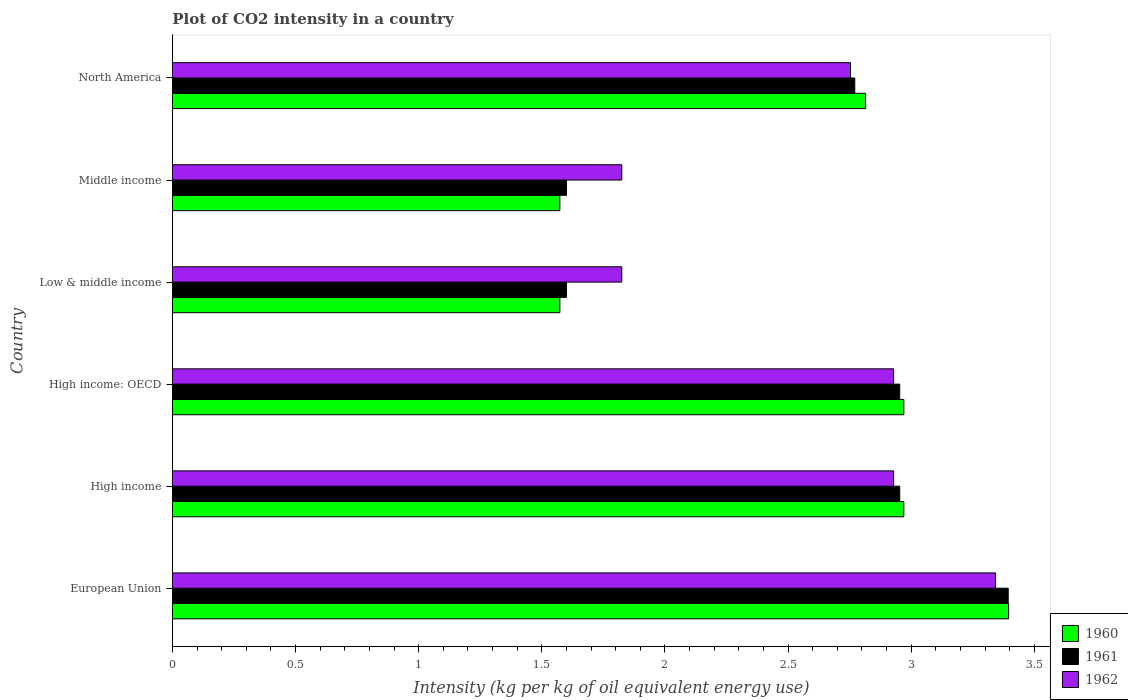How many bars are there on the 3rd tick from the top?
Offer a terse response. 3. What is the CO2 intensity in in 1962 in Low & middle income?
Give a very brief answer. 1.82. Across all countries, what is the maximum CO2 intensity in in 1962?
Offer a terse response. 3.34. Across all countries, what is the minimum CO2 intensity in in 1962?
Keep it short and to the point. 1.82. In which country was the CO2 intensity in in 1961 maximum?
Offer a very short reply. European Union. In which country was the CO2 intensity in in 1961 minimum?
Make the answer very short. Low & middle income. What is the total CO2 intensity in in 1960 in the graph?
Provide a short and direct response. 15.3. What is the difference between the CO2 intensity in in 1960 in High income: OECD and that in Middle income?
Your answer should be compact. 1.4. What is the difference between the CO2 intensity in in 1961 in North America and the CO2 intensity in in 1962 in High income?
Offer a very short reply. -0.16. What is the average CO2 intensity in in 1962 per country?
Keep it short and to the point. 2.6. What is the difference between the CO2 intensity in in 1962 and CO2 intensity in in 1960 in Middle income?
Offer a very short reply. 0.25. What is the ratio of the CO2 intensity in in 1961 in Low & middle income to that in North America?
Offer a very short reply. 0.58. Is the CO2 intensity in in 1962 in High income less than that in Middle income?
Provide a short and direct response. No. Is the difference between the CO2 intensity in in 1962 in High income and Middle income greater than the difference between the CO2 intensity in in 1960 in High income and Middle income?
Your response must be concise. No. What is the difference between the highest and the second highest CO2 intensity in in 1961?
Provide a succinct answer. 0.44. What is the difference between the highest and the lowest CO2 intensity in in 1960?
Give a very brief answer. 1.82. What does the 3rd bar from the top in Middle income represents?
Make the answer very short. 1960. What does the 1st bar from the bottom in North America represents?
Your answer should be compact. 1960. What is the difference between two consecutive major ticks on the X-axis?
Your response must be concise. 0.5. How many legend labels are there?
Make the answer very short. 3. How are the legend labels stacked?
Your answer should be compact. Vertical. What is the title of the graph?
Make the answer very short. Plot of CO2 intensity in a country. Does "1978" appear as one of the legend labels in the graph?
Offer a terse response. No. What is the label or title of the X-axis?
Make the answer very short. Intensity (kg per kg of oil equivalent energy use). What is the Intensity (kg per kg of oil equivalent energy use) in 1960 in European Union?
Your response must be concise. 3.4. What is the Intensity (kg per kg of oil equivalent energy use) in 1961 in European Union?
Keep it short and to the point. 3.39. What is the Intensity (kg per kg of oil equivalent energy use) in 1962 in European Union?
Give a very brief answer. 3.34. What is the Intensity (kg per kg of oil equivalent energy use) of 1960 in High income?
Make the answer very short. 2.97. What is the Intensity (kg per kg of oil equivalent energy use) of 1961 in High income?
Give a very brief answer. 2.95. What is the Intensity (kg per kg of oil equivalent energy use) of 1962 in High income?
Offer a terse response. 2.93. What is the Intensity (kg per kg of oil equivalent energy use) of 1960 in High income: OECD?
Offer a very short reply. 2.97. What is the Intensity (kg per kg of oil equivalent energy use) in 1961 in High income: OECD?
Keep it short and to the point. 2.95. What is the Intensity (kg per kg of oil equivalent energy use) of 1962 in High income: OECD?
Your answer should be very brief. 2.93. What is the Intensity (kg per kg of oil equivalent energy use) of 1960 in Low & middle income?
Offer a very short reply. 1.57. What is the Intensity (kg per kg of oil equivalent energy use) of 1961 in Low & middle income?
Make the answer very short. 1.6. What is the Intensity (kg per kg of oil equivalent energy use) of 1962 in Low & middle income?
Give a very brief answer. 1.82. What is the Intensity (kg per kg of oil equivalent energy use) of 1960 in Middle income?
Your answer should be very brief. 1.57. What is the Intensity (kg per kg of oil equivalent energy use) of 1961 in Middle income?
Keep it short and to the point. 1.6. What is the Intensity (kg per kg of oil equivalent energy use) of 1962 in Middle income?
Offer a terse response. 1.82. What is the Intensity (kg per kg of oil equivalent energy use) of 1960 in North America?
Provide a short and direct response. 2.81. What is the Intensity (kg per kg of oil equivalent energy use) of 1961 in North America?
Offer a very short reply. 2.77. What is the Intensity (kg per kg of oil equivalent energy use) of 1962 in North America?
Ensure brevity in your answer.  2.75. Across all countries, what is the maximum Intensity (kg per kg of oil equivalent energy use) of 1960?
Make the answer very short. 3.4. Across all countries, what is the maximum Intensity (kg per kg of oil equivalent energy use) in 1961?
Make the answer very short. 3.39. Across all countries, what is the maximum Intensity (kg per kg of oil equivalent energy use) of 1962?
Offer a very short reply. 3.34. Across all countries, what is the minimum Intensity (kg per kg of oil equivalent energy use) of 1960?
Make the answer very short. 1.57. Across all countries, what is the minimum Intensity (kg per kg of oil equivalent energy use) of 1961?
Your answer should be compact. 1.6. Across all countries, what is the minimum Intensity (kg per kg of oil equivalent energy use) in 1962?
Provide a short and direct response. 1.82. What is the total Intensity (kg per kg of oil equivalent energy use) in 1960 in the graph?
Provide a short and direct response. 15.3. What is the total Intensity (kg per kg of oil equivalent energy use) of 1961 in the graph?
Offer a terse response. 15.27. What is the total Intensity (kg per kg of oil equivalent energy use) in 1962 in the graph?
Ensure brevity in your answer.  15.6. What is the difference between the Intensity (kg per kg of oil equivalent energy use) in 1960 in European Union and that in High income?
Your answer should be compact. 0.43. What is the difference between the Intensity (kg per kg of oil equivalent energy use) in 1961 in European Union and that in High income?
Give a very brief answer. 0.44. What is the difference between the Intensity (kg per kg of oil equivalent energy use) of 1962 in European Union and that in High income?
Offer a terse response. 0.41. What is the difference between the Intensity (kg per kg of oil equivalent energy use) of 1960 in European Union and that in High income: OECD?
Give a very brief answer. 0.43. What is the difference between the Intensity (kg per kg of oil equivalent energy use) in 1961 in European Union and that in High income: OECD?
Provide a short and direct response. 0.44. What is the difference between the Intensity (kg per kg of oil equivalent energy use) in 1962 in European Union and that in High income: OECD?
Offer a very short reply. 0.41. What is the difference between the Intensity (kg per kg of oil equivalent energy use) of 1960 in European Union and that in Low & middle income?
Provide a short and direct response. 1.82. What is the difference between the Intensity (kg per kg of oil equivalent energy use) in 1961 in European Union and that in Low & middle income?
Make the answer very short. 1.79. What is the difference between the Intensity (kg per kg of oil equivalent energy use) of 1962 in European Union and that in Low & middle income?
Give a very brief answer. 1.52. What is the difference between the Intensity (kg per kg of oil equivalent energy use) of 1960 in European Union and that in Middle income?
Provide a succinct answer. 1.82. What is the difference between the Intensity (kg per kg of oil equivalent energy use) of 1961 in European Union and that in Middle income?
Provide a short and direct response. 1.79. What is the difference between the Intensity (kg per kg of oil equivalent energy use) of 1962 in European Union and that in Middle income?
Your response must be concise. 1.52. What is the difference between the Intensity (kg per kg of oil equivalent energy use) in 1960 in European Union and that in North America?
Keep it short and to the point. 0.58. What is the difference between the Intensity (kg per kg of oil equivalent energy use) of 1961 in European Union and that in North America?
Offer a terse response. 0.62. What is the difference between the Intensity (kg per kg of oil equivalent energy use) in 1962 in European Union and that in North America?
Ensure brevity in your answer.  0.59. What is the difference between the Intensity (kg per kg of oil equivalent energy use) in 1960 in High income and that in High income: OECD?
Offer a terse response. 0. What is the difference between the Intensity (kg per kg of oil equivalent energy use) in 1961 in High income and that in High income: OECD?
Provide a succinct answer. 0. What is the difference between the Intensity (kg per kg of oil equivalent energy use) in 1962 in High income and that in High income: OECD?
Your answer should be very brief. 0. What is the difference between the Intensity (kg per kg of oil equivalent energy use) in 1960 in High income and that in Low & middle income?
Your answer should be compact. 1.4. What is the difference between the Intensity (kg per kg of oil equivalent energy use) of 1961 in High income and that in Low & middle income?
Make the answer very short. 1.35. What is the difference between the Intensity (kg per kg of oil equivalent energy use) of 1962 in High income and that in Low & middle income?
Provide a short and direct response. 1.1. What is the difference between the Intensity (kg per kg of oil equivalent energy use) of 1960 in High income and that in Middle income?
Your response must be concise. 1.4. What is the difference between the Intensity (kg per kg of oil equivalent energy use) in 1961 in High income and that in Middle income?
Offer a very short reply. 1.35. What is the difference between the Intensity (kg per kg of oil equivalent energy use) of 1962 in High income and that in Middle income?
Your answer should be very brief. 1.1. What is the difference between the Intensity (kg per kg of oil equivalent energy use) of 1960 in High income and that in North America?
Provide a succinct answer. 0.16. What is the difference between the Intensity (kg per kg of oil equivalent energy use) in 1961 in High income and that in North America?
Your answer should be very brief. 0.18. What is the difference between the Intensity (kg per kg of oil equivalent energy use) of 1962 in High income and that in North America?
Provide a short and direct response. 0.18. What is the difference between the Intensity (kg per kg of oil equivalent energy use) in 1960 in High income: OECD and that in Low & middle income?
Your response must be concise. 1.4. What is the difference between the Intensity (kg per kg of oil equivalent energy use) of 1961 in High income: OECD and that in Low & middle income?
Make the answer very short. 1.35. What is the difference between the Intensity (kg per kg of oil equivalent energy use) in 1962 in High income: OECD and that in Low & middle income?
Your response must be concise. 1.1. What is the difference between the Intensity (kg per kg of oil equivalent energy use) of 1960 in High income: OECD and that in Middle income?
Your response must be concise. 1.4. What is the difference between the Intensity (kg per kg of oil equivalent energy use) of 1961 in High income: OECD and that in Middle income?
Provide a succinct answer. 1.35. What is the difference between the Intensity (kg per kg of oil equivalent energy use) of 1962 in High income: OECD and that in Middle income?
Provide a short and direct response. 1.1. What is the difference between the Intensity (kg per kg of oil equivalent energy use) of 1960 in High income: OECD and that in North America?
Provide a succinct answer. 0.16. What is the difference between the Intensity (kg per kg of oil equivalent energy use) in 1961 in High income: OECD and that in North America?
Your answer should be compact. 0.18. What is the difference between the Intensity (kg per kg of oil equivalent energy use) of 1962 in High income: OECD and that in North America?
Offer a terse response. 0.18. What is the difference between the Intensity (kg per kg of oil equivalent energy use) of 1960 in Low & middle income and that in Middle income?
Your response must be concise. 0. What is the difference between the Intensity (kg per kg of oil equivalent energy use) in 1961 in Low & middle income and that in Middle income?
Provide a short and direct response. 0. What is the difference between the Intensity (kg per kg of oil equivalent energy use) in 1960 in Low & middle income and that in North America?
Your response must be concise. -1.24. What is the difference between the Intensity (kg per kg of oil equivalent energy use) in 1961 in Low & middle income and that in North America?
Make the answer very short. -1.17. What is the difference between the Intensity (kg per kg of oil equivalent energy use) of 1962 in Low & middle income and that in North America?
Offer a terse response. -0.93. What is the difference between the Intensity (kg per kg of oil equivalent energy use) of 1960 in Middle income and that in North America?
Your response must be concise. -1.24. What is the difference between the Intensity (kg per kg of oil equivalent energy use) of 1961 in Middle income and that in North America?
Make the answer very short. -1.17. What is the difference between the Intensity (kg per kg of oil equivalent energy use) in 1962 in Middle income and that in North America?
Make the answer very short. -0.93. What is the difference between the Intensity (kg per kg of oil equivalent energy use) in 1960 in European Union and the Intensity (kg per kg of oil equivalent energy use) in 1961 in High income?
Offer a terse response. 0.44. What is the difference between the Intensity (kg per kg of oil equivalent energy use) of 1960 in European Union and the Intensity (kg per kg of oil equivalent energy use) of 1962 in High income?
Ensure brevity in your answer.  0.47. What is the difference between the Intensity (kg per kg of oil equivalent energy use) in 1961 in European Union and the Intensity (kg per kg of oil equivalent energy use) in 1962 in High income?
Provide a short and direct response. 0.47. What is the difference between the Intensity (kg per kg of oil equivalent energy use) of 1960 in European Union and the Intensity (kg per kg of oil equivalent energy use) of 1961 in High income: OECD?
Your response must be concise. 0.44. What is the difference between the Intensity (kg per kg of oil equivalent energy use) of 1960 in European Union and the Intensity (kg per kg of oil equivalent energy use) of 1962 in High income: OECD?
Provide a short and direct response. 0.47. What is the difference between the Intensity (kg per kg of oil equivalent energy use) in 1961 in European Union and the Intensity (kg per kg of oil equivalent energy use) in 1962 in High income: OECD?
Offer a very short reply. 0.47. What is the difference between the Intensity (kg per kg of oil equivalent energy use) of 1960 in European Union and the Intensity (kg per kg of oil equivalent energy use) of 1961 in Low & middle income?
Offer a very short reply. 1.8. What is the difference between the Intensity (kg per kg of oil equivalent energy use) of 1960 in European Union and the Intensity (kg per kg of oil equivalent energy use) of 1962 in Low & middle income?
Offer a terse response. 1.57. What is the difference between the Intensity (kg per kg of oil equivalent energy use) of 1961 in European Union and the Intensity (kg per kg of oil equivalent energy use) of 1962 in Low & middle income?
Give a very brief answer. 1.57. What is the difference between the Intensity (kg per kg of oil equivalent energy use) in 1960 in European Union and the Intensity (kg per kg of oil equivalent energy use) in 1961 in Middle income?
Provide a short and direct response. 1.8. What is the difference between the Intensity (kg per kg of oil equivalent energy use) of 1960 in European Union and the Intensity (kg per kg of oil equivalent energy use) of 1962 in Middle income?
Provide a succinct answer. 1.57. What is the difference between the Intensity (kg per kg of oil equivalent energy use) of 1961 in European Union and the Intensity (kg per kg of oil equivalent energy use) of 1962 in Middle income?
Offer a very short reply. 1.57. What is the difference between the Intensity (kg per kg of oil equivalent energy use) of 1960 in European Union and the Intensity (kg per kg of oil equivalent energy use) of 1961 in North America?
Provide a short and direct response. 0.62. What is the difference between the Intensity (kg per kg of oil equivalent energy use) in 1960 in European Union and the Intensity (kg per kg of oil equivalent energy use) in 1962 in North America?
Your answer should be very brief. 0.64. What is the difference between the Intensity (kg per kg of oil equivalent energy use) of 1961 in European Union and the Intensity (kg per kg of oil equivalent energy use) of 1962 in North America?
Your answer should be compact. 0.64. What is the difference between the Intensity (kg per kg of oil equivalent energy use) of 1960 in High income and the Intensity (kg per kg of oil equivalent energy use) of 1961 in High income: OECD?
Your response must be concise. 0.02. What is the difference between the Intensity (kg per kg of oil equivalent energy use) of 1960 in High income and the Intensity (kg per kg of oil equivalent energy use) of 1962 in High income: OECD?
Provide a succinct answer. 0.04. What is the difference between the Intensity (kg per kg of oil equivalent energy use) of 1961 in High income and the Intensity (kg per kg of oil equivalent energy use) of 1962 in High income: OECD?
Ensure brevity in your answer.  0.02. What is the difference between the Intensity (kg per kg of oil equivalent energy use) of 1960 in High income and the Intensity (kg per kg of oil equivalent energy use) of 1961 in Low & middle income?
Provide a short and direct response. 1.37. What is the difference between the Intensity (kg per kg of oil equivalent energy use) in 1960 in High income and the Intensity (kg per kg of oil equivalent energy use) in 1962 in Low & middle income?
Offer a terse response. 1.15. What is the difference between the Intensity (kg per kg of oil equivalent energy use) of 1961 in High income and the Intensity (kg per kg of oil equivalent energy use) of 1962 in Low & middle income?
Keep it short and to the point. 1.13. What is the difference between the Intensity (kg per kg of oil equivalent energy use) in 1960 in High income and the Intensity (kg per kg of oil equivalent energy use) in 1961 in Middle income?
Make the answer very short. 1.37. What is the difference between the Intensity (kg per kg of oil equivalent energy use) of 1960 in High income and the Intensity (kg per kg of oil equivalent energy use) of 1962 in Middle income?
Keep it short and to the point. 1.15. What is the difference between the Intensity (kg per kg of oil equivalent energy use) in 1961 in High income and the Intensity (kg per kg of oil equivalent energy use) in 1962 in Middle income?
Offer a very short reply. 1.13. What is the difference between the Intensity (kg per kg of oil equivalent energy use) of 1960 in High income and the Intensity (kg per kg of oil equivalent energy use) of 1961 in North America?
Offer a very short reply. 0.2. What is the difference between the Intensity (kg per kg of oil equivalent energy use) in 1960 in High income and the Intensity (kg per kg of oil equivalent energy use) in 1962 in North America?
Offer a very short reply. 0.22. What is the difference between the Intensity (kg per kg of oil equivalent energy use) of 1961 in High income and the Intensity (kg per kg of oil equivalent energy use) of 1962 in North America?
Ensure brevity in your answer.  0.2. What is the difference between the Intensity (kg per kg of oil equivalent energy use) of 1960 in High income: OECD and the Intensity (kg per kg of oil equivalent energy use) of 1961 in Low & middle income?
Give a very brief answer. 1.37. What is the difference between the Intensity (kg per kg of oil equivalent energy use) in 1960 in High income: OECD and the Intensity (kg per kg of oil equivalent energy use) in 1962 in Low & middle income?
Provide a short and direct response. 1.15. What is the difference between the Intensity (kg per kg of oil equivalent energy use) in 1961 in High income: OECD and the Intensity (kg per kg of oil equivalent energy use) in 1962 in Low & middle income?
Keep it short and to the point. 1.13. What is the difference between the Intensity (kg per kg of oil equivalent energy use) of 1960 in High income: OECD and the Intensity (kg per kg of oil equivalent energy use) of 1961 in Middle income?
Offer a very short reply. 1.37. What is the difference between the Intensity (kg per kg of oil equivalent energy use) in 1960 in High income: OECD and the Intensity (kg per kg of oil equivalent energy use) in 1962 in Middle income?
Provide a short and direct response. 1.15. What is the difference between the Intensity (kg per kg of oil equivalent energy use) in 1961 in High income: OECD and the Intensity (kg per kg of oil equivalent energy use) in 1962 in Middle income?
Offer a very short reply. 1.13. What is the difference between the Intensity (kg per kg of oil equivalent energy use) of 1960 in High income: OECD and the Intensity (kg per kg of oil equivalent energy use) of 1961 in North America?
Make the answer very short. 0.2. What is the difference between the Intensity (kg per kg of oil equivalent energy use) in 1960 in High income: OECD and the Intensity (kg per kg of oil equivalent energy use) in 1962 in North America?
Make the answer very short. 0.22. What is the difference between the Intensity (kg per kg of oil equivalent energy use) of 1961 in High income: OECD and the Intensity (kg per kg of oil equivalent energy use) of 1962 in North America?
Provide a succinct answer. 0.2. What is the difference between the Intensity (kg per kg of oil equivalent energy use) in 1960 in Low & middle income and the Intensity (kg per kg of oil equivalent energy use) in 1961 in Middle income?
Ensure brevity in your answer.  -0.03. What is the difference between the Intensity (kg per kg of oil equivalent energy use) in 1960 in Low & middle income and the Intensity (kg per kg of oil equivalent energy use) in 1962 in Middle income?
Provide a succinct answer. -0.25. What is the difference between the Intensity (kg per kg of oil equivalent energy use) in 1961 in Low & middle income and the Intensity (kg per kg of oil equivalent energy use) in 1962 in Middle income?
Give a very brief answer. -0.22. What is the difference between the Intensity (kg per kg of oil equivalent energy use) in 1960 in Low & middle income and the Intensity (kg per kg of oil equivalent energy use) in 1961 in North America?
Your answer should be compact. -1.2. What is the difference between the Intensity (kg per kg of oil equivalent energy use) of 1960 in Low & middle income and the Intensity (kg per kg of oil equivalent energy use) of 1962 in North America?
Your response must be concise. -1.18. What is the difference between the Intensity (kg per kg of oil equivalent energy use) of 1961 in Low & middle income and the Intensity (kg per kg of oil equivalent energy use) of 1962 in North America?
Offer a terse response. -1.15. What is the difference between the Intensity (kg per kg of oil equivalent energy use) in 1960 in Middle income and the Intensity (kg per kg of oil equivalent energy use) in 1961 in North America?
Ensure brevity in your answer.  -1.2. What is the difference between the Intensity (kg per kg of oil equivalent energy use) in 1960 in Middle income and the Intensity (kg per kg of oil equivalent energy use) in 1962 in North America?
Offer a very short reply. -1.18. What is the difference between the Intensity (kg per kg of oil equivalent energy use) of 1961 in Middle income and the Intensity (kg per kg of oil equivalent energy use) of 1962 in North America?
Your answer should be very brief. -1.15. What is the average Intensity (kg per kg of oil equivalent energy use) of 1960 per country?
Offer a terse response. 2.55. What is the average Intensity (kg per kg of oil equivalent energy use) in 1961 per country?
Offer a very short reply. 2.55. What is the average Intensity (kg per kg of oil equivalent energy use) of 1962 per country?
Ensure brevity in your answer.  2.6. What is the difference between the Intensity (kg per kg of oil equivalent energy use) of 1960 and Intensity (kg per kg of oil equivalent energy use) of 1961 in European Union?
Make the answer very short. 0. What is the difference between the Intensity (kg per kg of oil equivalent energy use) of 1960 and Intensity (kg per kg of oil equivalent energy use) of 1962 in European Union?
Offer a terse response. 0.05. What is the difference between the Intensity (kg per kg of oil equivalent energy use) in 1961 and Intensity (kg per kg of oil equivalent energy use) in 1962 in European Union?
Offer a terse response. 0.05. What is the difference between the Intensity (kg per kg of oil equivalent energy use) in 1960 and Intensity (kg per kg of oil equivalent energy use) in 1961 in High income?
Your answer should be compact. 0.02. What is the difference between the Intensity (kg per kg of oil equivalent energy use) of 1960 and Intensity (kg per kg of oil equivalent energy use) of 1962 in High income?
Your answer should be compact. 0.04. What is the difference between the Intensity (kg per kg of oil equivalent energy use) of 1961 and Intensity (kg per kg of oil equivalent energy use) of 1962 in High income?
Ensure brevity in your answer.  0.02. What is the difference between the Intensity (kg per kg of oil equivalent energy use) of 1960 and Intensity (kg per kg of oil equivalent energy use) of 1961 in High income: OECD?
Give a very brief answer. 0.02. What is the difference between the Intensity (kg per kg of oil equivalent energy use) of 1960 and Intensity (kg per kg of oil equivalent energy use) of 1962 in High income: OECD?
Make the answer very short. 0.04. What is the difference between the Intensity (kg per kg of oil equivalent energy use) in 1961 and Intensity (kg per kg of oil equivalent energy use) in 1962 in High income: OECD?
Offer a very short reply. 0.02. What is the difference between the Intensity (kg per kg of oil equivalent energy use) in 1960 and Intensity (kg per kg of oil equivalent energy use) in 1961 in Low & middle income?
Offer a terse response. -0.03. What is the difference between the Intensity (kg per kg of oil equivalent energy use) of 1960 and Intensity (kg per kg of oil equivalent energy use) of 1962 in Low & middle income?
Your response must be concise. -0.25. What is the difference between the Intensity (kg per kg of oil equivalent energy use) of 1961 and Intensity (kg per kg of oil equivalent energy use) of 1962 in Low & middle income?
Provide a short and direct response. -0.22. What is the difference between the Intensity (kg per kg of oil equivalent energy use) in 1960 and Intensity (kg per kg of oil equivalent energy use) in 1961 in Middle income?
Your response must be concise. -0.03. What is the difference between the Intensity (kg per kg of oil equivalent energy use) in 1960 and Intensity (kg per kg of oil equivalent energy use) in 1962 in Middle income?
Offer a terse response. -0.25. What is the difference between the Intensity (kg per kg of oil equivalent energy use) in 1961 and Intensity (kg per kg of oil equivalent energy use) in 1962 in Middle income?
Offer a terse response. -0.22. What is the difference between the Intensity (kg per kg of oil equivalent energy use) in 1960 and Intensity (kg per kg of oil equivalent energy use) in 1961 in North America?
Your response must be concise. 0.04. What is the difference between the Intensity (kg per kg of oil equivalent energy use) of 1960 and Intensity (kg per kg of oil equivalent energy use) of 1962 in North America?
Provide a succinct answer. 0.06. What is the difference between the Intensity (kg per kg of oil equivalent energy use) of 1961 and Intensity (kg per kg of oil equivalent energy use) of 1962 in North America?
Make the answer very short. 0.02. What is the ratio of the Intensity (kg per kg of oil equivalent energy use) of 1960 in European Union to that in High income?
Provide a short and direct response. 1.14. What is the ratio of the Intensity (kg per kg of oil equivalent energy use) of 1961 in European Union to that in High income?
Provide a succinct answer. 1.15. What is the ratio of the Intensity (kg per kg of oil equivalent energy use) in 1962 in European Union to that in High income?
Keep it short and to the point. 1.14. What is the ratio of the Intensity (kg per kg of oil equivalent energy use) in 1960 in European Union to that in High income: OECD?
Your response must be concise. 1.14. What is the ratio of the Intensity (kg per kg of oil equivalent energy use) of 1961 in European Union to that in High income: OECD?
Your answer should be compact. 1.15. What is the ratio of the Intensity (kg per kg of oil equivalent energy use) in 1962 in European Union to that in High income: OECD?
Give a very brief answer. 1.14. What is the ratio of the Intensity (kg per kg of oil equivalent energy use) in 1960 in European Union to that in Low & middle income?
Give a very brief answer. 2.16. What is the ratio of the Intensity (kg per kg of oil equivalent energy use) in 1961 in European Union to that in Low & middle income?
Your answer should be very brief. 2.12. What is the ratio of the Intensity (kg per kg of oil equivalent energy use) in 1962 in European Union to that in Low & middle income?
Make the answer very short. 1.83. What is the ratio of the Intensity (kg per kg of oil equivalent energy use) of 1960 in European Union to that in Middle income?
Provide a succinct answer. 2.16. What is the ratio of the Intensity (kg per kg of oil equivalent energy use) in 1961 in European Union to that in Middle income?
Your response must be concise. 2.12. What is the ratio of the Intensity (kg per kg of oil equivalent energy use) in 1962 in European Union to that in Middle income?
Your response must be concise. 1.83. What is the ratio of the Intensity (kg per kg of oil equivalent energy use) in 1960 in European Union to that in North America?
Ensure brevity in your answer.  1.21. What is the ratio of the Intensity (kg per kg of oil equivalent energy use) in 1961 in European Union to that in North America?
Your answer should be compact. 1.22. What is the ratio of the Intensity (kg per kg of oil equivalent energy use) in 1962 in European Union to that in North America?
Your response must be concise. 1.21. What is the ratio of the Intensity (kg per kg of oil equivalent energy use) in 1960 in High income to that in High income: OECD?
Provide a short and direct response. 1. What is the ratio of the Intensity (kg per kg of oil equivalent energy use) in 1961 in High income to that in High income: OECD?
Offer a terse response. 1. What is the ratio of the Intensity (kg per kg of oil equivalent energy use) of 1962 in High income to that in High income: OECD?
Give a very brief answer. 1. What is the ratio of the Intensity (kg per kg of oil equivalent energy use) of 1960 in High income to that in Low & middle income?
Your answer should be very brief. 1.89. What is the ratio of the Intensity (kg per kg of oil equivalent energy use) in 1961 in High income to that in Low & middle income?
Provide a short and direct response. 1.85. What is the ratio of the Intensity (kg per kg of oil equivalent energy use) in 1962 in High income to that in Low & middle income?
Your answer should be compact. 1.6. What is the ratio of the Intensity (kg per kg of oil equivalent energy use) of 1960 in High income to that in Middle income?
Ensure brevity in your answer.  1.89. What is the ratio of the Intensity (kg per kg of oil equivalent energy use) in 1961 in High income to that in Middle income?
Your response must be concise. 1.85. What is the ratio of the Intensity (kg per kg of oil equivalent energy use) of 1962 in High income to that in Middle income?
Ensure brevity in your answer.  1.6. What is the ratio of the Intensity (kg per kg of oil equivalent energy use) in 1960 in High income to that in North America?
Make the answer very short. 1.06. What is the ratio of the Intensity (kg per kg of oil equivalent energy use) of 1961 in High income to that in North America?
Offer a terse response. 1.07. What is the ratio of the Intensity (kg per kg of oil equivalent energy use) of 1962 in High income to that in North America?
Provide a short and direct response. 1.06. What is the ratio of the Intensity (kg per kg of oil equivalent energy use) of 1960 in High income: OECD to that in Low & middle income?
Your answer should be very brief. 1.89. What is the ratio of the Intensity (kg per kg of oil equivalent energy use) in 1961 in High income: OECD to that in Low & middle income?
Make the answer very short. 1.85. What is the ratio of the Intensity (kg per kg of oil equivalent energy use) of 1962 in High income: OECD to that in Low & middle income?
Your answer should be very brief. 1.6. What is the ratio of the Intensity (kg per kg of oil equivalent energy use) in 1960 in High income: OECD to that in Middle income?
Provide a succinct answer. 1.89. What is the ratio of the Intensity (kg per kg of oil equivalent energy use) of 1961 in High income: OECD to that in Middle income?
Keep it short and to the point. 1.85. What is the ratio of the Intensity (kg per kg of oil equivalent energy use) in 1962 in High income: OECD to that in Middle income?
Offer a terse response. 1.6. What is the ratio of the Intensity (kg per kg of oil equivalent energy use) in 1960 in High income: OECD to that in North America?
Offer a terse response. 1.06. What is the ratio of the Intensity (kg per kg of oil equivalent energy use) of 1961 in High income: OECD to that in North America?
Your answer should be very brief. 1.07. What is the ratio of the Intensity (kg per kg of oil equivalent energy use) of 1962 in High income: OECD to that in North America?
Ensure brevity in your answer.  1.06. What is the ratio of the Intensity (kg per kg of oil equivalent energy use) of 1961 in Low & middle income to that in Middle income?
Provide a short and direct response. 1. What is the ratio of the Intensity (kg per kg of oil equivalent energy use) in 1962 in Low & middle income to that in Middle income?
Ensure brevity in your answer.  1. What is the ratio of the Intensity (kg per kg of oil equivalent energy use) of 1960 in Low & middle income to that in North America?
Ensure brevity in your answer.  0.56. What is the ratio of the Intensity (kg per kg of oil equivalent energy use) of 1961 in Low & middle income to that in North America?
Make the answer very short. 0.58. What is the ratio of the Intensity (kg per kg of oil equivalent energy use) in 1962 in Low & middle income to that in North America?
Offer a terse response. 0.66. What is the ratio of the Intensity (kg per kg of oil equivalent energy use) of 1960 in Middle income to that in North America?
Ensure brevity in your answer.  0.56. What is the ratio of the Intensity (kg per kg of oil equivalent energy use) in 1961 in Middle income to that in North America?
Offer a terse response. 0.58. What is the ratio of the Intensity (kg per kg of oil equivalent energy use) of 1962 in Middle income to that in North America?
Give a very brief answer. 0.66. What is the difference between the highest and the second highest Intensity (kg per kg of oil equivalent energy use) in 1960?
Offer a terse response. 0.43. What is the difference between the highest and the second highest Intensity (kg per kg of oil equivalent energy use) in 1961?
Your response must be concise. 0.44. What is the difference between the highest and the second highest Intensity (kg per kg of oil equivalent energy use) in 1962?
Your answer should be very brief. 0.41. What is the difference between the highest and the lowest Intensity (kg per kg of oil equivalent energy use) of 1960?
Give a very brief answer. 1.82. What is the difference between the highest and the lowest Intensity (kg per kg of oil equivalent energy use) in 1961?
Keep it short and to the point. 1.79. What is the difference between the highest and the lowest Intensity (kg per kg of oil equivalent energy use) of 1962?
Provide a succinct answer. 1.52. 